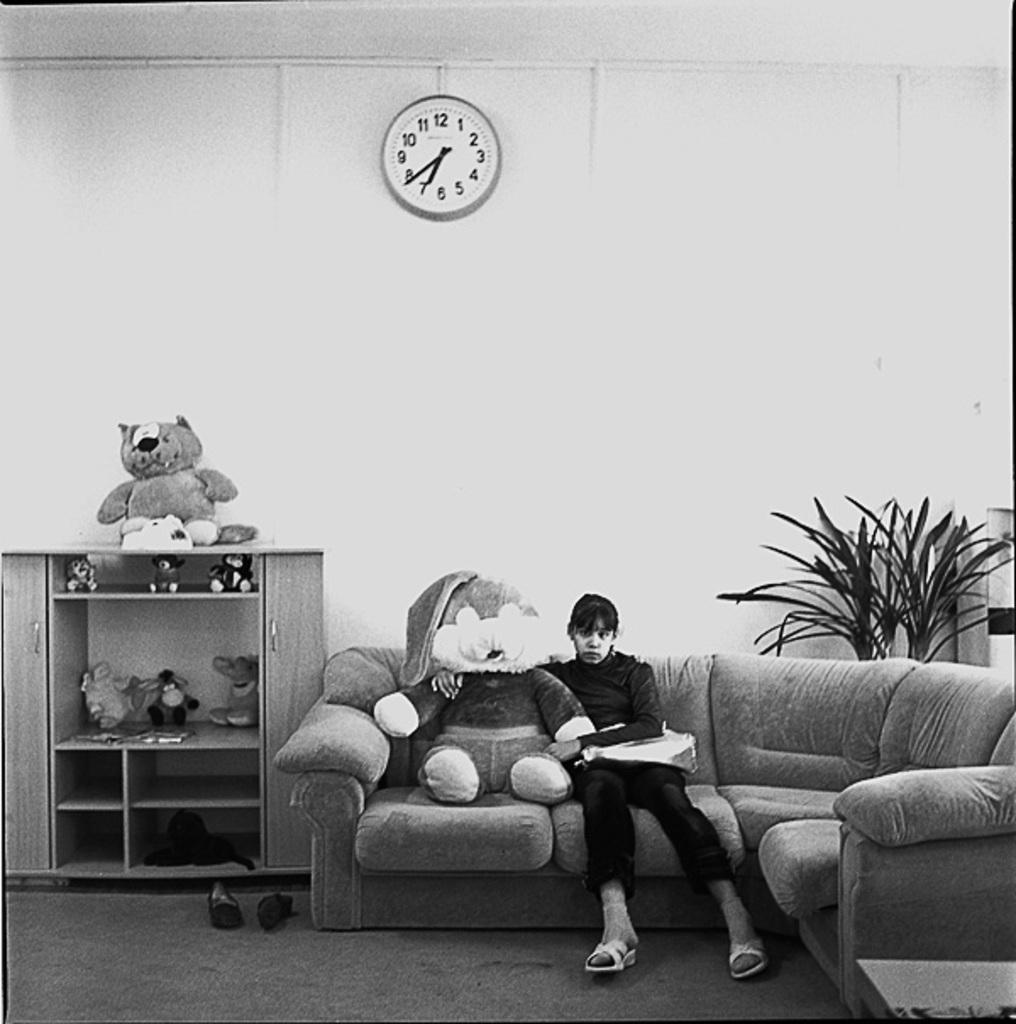What is the girl doing in the image? The girl is sitting on a sofa in the image. What object is the girl holding or interacting with? The girl has a doll with her in the image. What time-telling device is visible in the image? There is a wall clock visible in the image. What type of vegetation is on the right side of the image? There are plants on the right side of the image. How many cows can be seen grazing in the background of the image? There are no cows present in the image; it features a girl sitting on a sofa with a doll and plants on the right side. 